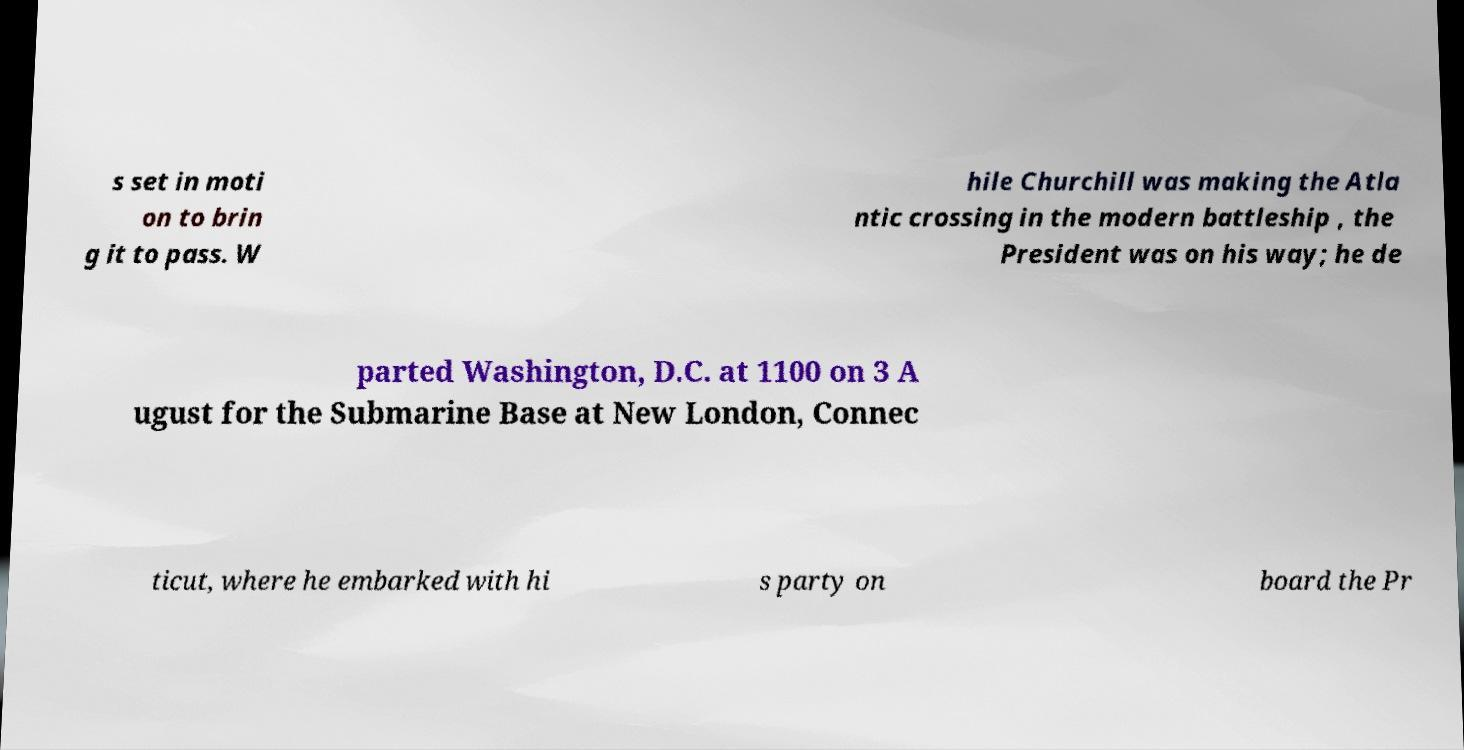For documentation purposes, I need the text within this image transcribed. Could you provide that? s set in moti on to brin g it to pass. W hile Churchill was making the Atla ntic crossing in the modern battleship , the President was on his way; he de parted Washington, D.C. at 1100 on 3 A ugust for the Submarine Base at New London, Connec ticut, where he embarked with hi s party on board the Pr 